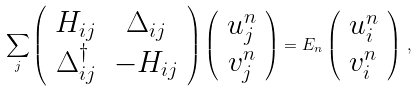Convert formula to latex. <formula><loc_0><loc_0><loc_500><loc_500>\sum _ { j } \left ( \begin{array} { c c } H _ { i j } & \Delta _ { i j } \\ \Delta _ { i j } ^ { \dagger } & - H _ { i j } \end{array} \right ) \left ( \begin{array} { c } u _ { j } ^ { n } \\ v _ { j } ^ { n } \end{array} \right ) = E _ { n } \left ( \begin{array} { c } u _ { i } ^ { n } \\ v _ { i } ^ { n } \end{array} \right ) \, ,</formula> 